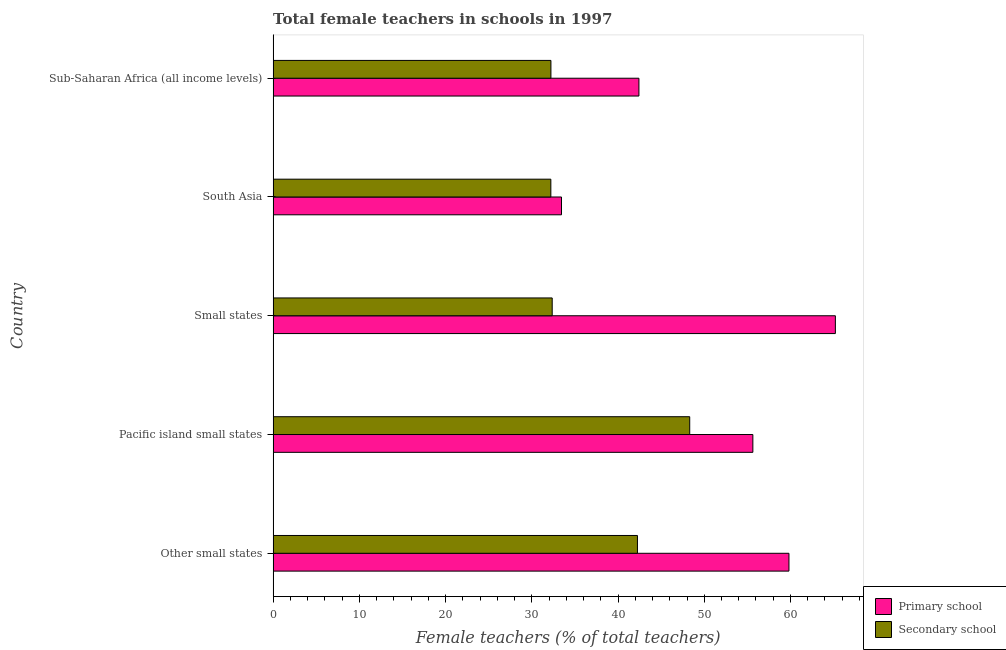How many groups of bars are there?
Provide a succinct answer. 5. How many bars are there on the 4th tick from the top?
Your answer should be very brief. 2. How many bars are there on the 3rd tick from the bottom?
Your answer should be very brief. 2. What is the label of the 3rd group of bars from the top?
Your answer should be compact. Small states. What is the percentage of female teachers in primary schools in Other small states?
Give a very brief answer. 59.82. Across all countries, what is the maximum percentage of female teachers in primary schools?
Give a very brief answer. 65.21. Across all countries, what is the minimum percentage of female teachers in secondary schools?
Your answer should be very brief. 32.21. In which country was the percentage of female teachers in primary schools maximum?
Keep it short and to the point. Small states. What is the total percentage of female teachers in primary schools in the graph?
Offer a very short reply. 256.54. What is the difference between the percentage of female teachers in secondary schools in Other small states and that in Sub-Saharan Africa (all income levels)?
Your answer should be compact. 10.04. What is the difference between the percentage of female teachers in secondary schools in Pacific island small states and the percentage of female teachers in primary schools in Sub-Saharan Africa (all income levels)?
Make the answer very short. 5.89. What is the average percentage of female teachers in secondary schools per country?
Your answer should be very brief. 37.47. What is the difference between the percentage of female teachers in secondary schools and percentage of female teachers in primary schools in Other small states?
Your answer should be compact. -17.57. In how many countries, is the percentage of female teachers in primary schools greater than 18 %?
Keep it short and to the point. 5. What is the ratio of the percentage of female teachers in primary schools in Small states to that in Sub-Saharan Africa (all income levels)?
Make the answer very short. 1.54. Is the percentage of female teachers in secondary schools in Pacific island small states less than that in South Asia?
Your response must be concise. No. Is the difference between the percentage of female teachers in secondary schools in Pacific island small states and South Asia greater than the difference between the percentage of female teachers in primary schools in Pacific island small states and South Asia?
Ensure brevity in your answer.  No. What is the difference between the highest and the second highest percentage of female teachers in secondary schools?
Your response must be concise. 6.06. What is the difference between the highest and the lowest percentage of female teachers in primary schools?
Provide a short and direct response. 31.76. Is the sum of the percentage of female teachers in primary schools in Pacific island small states and Small states greater than the maximum percentage of female teachers in secondary schools across all countries?
Your answer should be very brief. Yes. What does the 2nd bar from the top in South Asia represents?
Your response must be concise. Primary school. What does the 2nd bar from the bottom in Pacific island small states represents?
Offer a terse response. Secondary school. How many bars are there?
Offer a very short reply. 10. Are all the bars in the graph horizontal?
Give a very brief answer. Yes. How many countries are there in the graph?
Ensure brevity in your answer.  5. Are the values on the major ticks of X-axis written in scientific E-notation?
Provide a short and direct response. No. Where does the legend appear in the graph?
Your response must be concise. Bottom right. What is the title of the graph?
Provide a short and direct response. Total female teachers in schools in 1997. What is the label or title of the X-axis?
Make the answer very short. Female teachers (% of total teachers). What is the Female teachers (% of total teachers) of Primary school in Other small states?
Your response must be concise. 59.82. What is the Female teachers (% of total teachers) in Secondary school in Other small states?
Offer a terse response. 42.25. What is the Female teachers (% of total teachers) in Primary school in Pacific island small states?
Your response must be concise. 55.64. What is the Female teachers (% of total teachers) of Secondary school in Pacific island small states?
Your answer should be very brief. 48.32. What is the Female teachers (% of total teachers) in Primary school in Small states?
Keep it short and to the point. 65.21. What is the Female teachers (% of total teachers) in Secondary school in Small states?
Offer a very short reply. 32.37. What is the Female teachers (% of total teachers) in Primary school in South Asia?
Provide a succinct answer. 33.45. What is the Female teachers (% of total teachers) of Secondary school in South Asia?
Ensure brevity in your answer.  32.21. What is the Female teachers (% of total teachers) in Primary school in Sub-Saharan Africa (all income levels)?
Give a very brief answer. 42.43. What is the Female teachers (% of total teachers) of Secondary school in Sub-Saharan Africa (all income levels)?
Make the answer very short. 32.22. Across all countries, what is the maximum Female teachers (% of total teachers) of Primary school?
Your response must be concise. 65.21. Across all countries, what is the maximum Female teachers (% of total teachers) in Secondary school?
Your answer should be compact. 48.32. Across all countries, what is the minimum Female teachers (% of total teachers) of Primary school?
Offer a very short reply. 33.45. Across all countries, what is the minimum Female teachers (% of total teachers) in Secondary school?
Provide a succinct answer. 32.21. What is the total Female teachers (% of total teachers) in Primary school in the graph?
Your answer should be compact. 256.54. What is the total Female teachers (% of total teachers) in Secondary school in the graph?
Provide a short and direct response. 187.37. What is the difference between the Female teachers (% of total teachers) of Primary school in Other small states and that in Pacific island small states?
Your answer should be very brief. 4.19. What is the difference between the Female teachers (% of total teachers) in Secondary school in Other small states and that in Pacific island small states?
Offer a terse response. -6.06. What is the difference between the Female teachers (% of total teachers) in Primary school in Other small states and that in Small states?
Provide a short and direct response. -5.39. What is the difference between the Female teachers (% of total teachers) in Secondary school in Other small states and that in Small states?
Your answer should be very brief. 9.89. What is the difference between the Female teachers (% of total teachers) in Primary school in Other small states and that in South Asia?
Your answer should be very brief. 26.38. What is the difference between the Female teachers (% of total teachers) in Secondary school in Other small states and that in South Asia?
Provide a succinct answer. 10.04. What is the difference between the Female teachers (% of total teachers) in Primary school in Other small states and that in Sub-Saharan Africa (all income levels)?
Your response must be concise. 17.4. What is the difference between the Female teachers (% of total teachers) of Secondary school in Other small states and that in Sub-Saharan Africa (all income levels)?
Keep it short and to the point. 10.04. What is the difference between the Female teachers (% of total teachers) in Primary school in Pacific island small states and that in Small states?
Offer a terse response. -9.57. What is the difference between the Female teachers (% of total teachers) in Secondary school in Pacific island small states and that in Small states?
Provide a short and direct response. 15.95. What is the difference between the Female teachers (% of total teachers) in Primary school in Pacific island small states and that in South Asia?
Provide a succinct answer. 22.19. What is the difference between the Female teachers (% of total teachers) in Secondary school in Pacific island small states and that in South Asia?
Keep it short and to the point. 16.11. What is the difference between the Female teachers (% of total teachers) of Primary school in Pacific island small states and that in Sub-Saharan Africa (all income levels)?
Ensure brevity in your answer.  13.21. What is the difference between the Female teachers (% of total teachers) in Secondary school in Pacific island small states and that in Sub-Saharan Africa (all income levels)?
Provide a short and direct response. 16.1. What is the difference between the Female teachers (% of total teachers) in Primary school in Small states and that in South Asia?
Provide a succinct answer. 31.76. What is the difference between the Female teachers (% of total teachers) of Secondary school in Small states and that in South Asia?
Your response must be concise. 0.16. What is the difference between the Female teachers (% of total teachers) in Primary school in Small states and that in Sub-Saharan Africa (all income levels)?
Provide a short and direct response. 22.78. What is the difference between the Female teachers (% of total teachers) in Secondary school in Small states and that in Sub-Saharan Africa (all income levels)?
Provide a succinct answer. 0.15. What is the difference between the Female teachers (% of total teachers) in Primary school in South Asia and that in Sub-Saharan Africa (all income levels)?
Offer a very short reply. -8.98. What is the difference between the Female teachers (% of total teachers) of Secondary school in South Asia and that in Sub-Saharan Africa (all income levels)?
Give a very brief answer. -0.01. What is the difference between the Female teachers (% of total teachers) of Primary school in Other small states and the Female teachers (% of total teachers) of Secondary school in Pacific island small states?
Your answer should be very brief. 11.51. What is the difference between the Female teachers (% of total teachers) of Primary school in Other small states and the Female teachers (% of total teachers) of Secondary school in Small states?
Offer a terse response. 27.46. What is the difference between the Female teachers (% of total teachers) in Primary school in Other small states and the Female teachers (% of total teachers) in Secondary school in South Asia?
Your response must be concise. 27.61. What is the difference between the Female teachers (% of total teachers) of Primary school in Other small states and the Female teachers (% of total teachers) of Secondary school in Sub-Saharan Africa (all income levels)?
Keep it short and to the point. 27.61. What is the difference between the Female teachers (% of total teachers) of Primary school in Pacific island small states and the Female teachers (% of total teachers) of Secondary school in Small states?
Your answer should be very brief. 23.27. What is the difference between the Female teachers (% of total teachers) of Primary school in Pacific island small states and the Female teachers (% of total teachers) of Secondary school in South Asia?
Provide a short and direct response. 23.43. What is the difference between the Female teachers (% of total teachers) of Primary school in Pacific island small states and the Female teachers (% of total teachers) of Secondary school in Sub-Saharan Africa (all income levels)?
Your answer should be compact. 23.42. What is the difference between the Female teachers (% of total teachers) of Primary school in Small states and the Female teachers (% of total teachers) of Secondary school in South Asia?
Your answer should be very brief. 33. What is the difference between the Female teachers (% of total teachers) of Primary school in Small states and the Female teachers (% of total teachers) of Secondary school in Sub-Saharan Africa (all income levels)?
Your response must be concise. 32.99. What is the difference between the Female teachers (% of total teachers) in Primary school in South Asia and the Female teachers (% of total teachers) in Secondary school in Sub-Saharan Africa (all income levels)?
Make the answer very short. 1.23. What is the average Female teachers (% of total teachers) in Primary school per country?
Your answer should be compact. 51.31. What is the average Female teachers (% of total teachers) of Secondary school per country?
Make the answer very short. 37.47. What is the difference between the Female teachers (% of total teachers) in Primary school and Female teachers (% of total teachers) in Secondary school in Other small states?
Provide a short and direct response. 17.57. What is the difference between the Female teachers (% of total teachers) of Primary school and Female teachers (% of total teachers) of Secondary school in Pacific island small states?
Your answer should be very brief. 7.32. What is the difference between the Female teachers (% of total teachers) in Primary school and Female teachers (% of total teachers) in Secondary school in Small states?
Keep it short and to the point. 32.84. What is the difference between the Female teachers (% of total teachers) in Primary school and Female teachers (% of total teachers) in Secondary school in South Asia?
Ensure brevity in your answer.  1.24. What is the difference between the Female teachers (% of total teachers) in Primary school and Female teachers (% of total teachers) in Secondary school in Sub-Saharan Africa (all income levels)?
Make the answer very short. 10.21. What is the ratio of the Female teachers (% of total teachers) in Primary school in Other small states to that in Pacific island small states?
Make the answer very short. 1.08. What is the ratio of the Female teachers (% of total teachers) of Secondary school in Other small states to that in Pacific island small states?
Your response must be concise. 0.87. What is the ratio of the Female teachers (% of total teachers) of Primary school in Other small states to that in Small states?
Keep it short and to the point. 0.92. What is the ratio of the Female teachers (% of total teachers) in Secondary school in Other small states to that in Small states?
Provide a succinct answer. 1.31. What is the ratio of the Female teachers (% of total teachers) of Primary school in Other small states to that in South Asia?
Give a very brief answer. 1.79. What is the ratio of the Female teachers (% of total teachers) in Secondary school in Other small states to that in South Asia?
Offer a terse response. 1.31. What is the ratio of the Female teachers (% of total teachers) in Primary school in Other small states to that in Sub-Saharan Africa (all income levels)?
Give a very brief answer. 1.41. What is the ratio of the Female teachers (% of total teachers) in Secondary school in Other small states to that in Sub-Saharan Africa (all income levels)?
Give a very brief answer. 1.31. What is the ratio of the Female teachers (% of total teachers) in Primary school in Pacific island small states to that in Small states?
Ensure brevity in your answer.  0.85. What is the ratio of the Female teachers (% of total teachers) of Secondary school in Pacific island small states to that in Small states?
Your response must be concise. 1.49. What is the ratio of the Female teachers (% of total teachers) of Primary school in Pacific island small states to that in South Asia?
Your answer should be compact. 1.66. What is the ratio of the Female teachers (% of total teachers) of Primary school in Pacific island small states to that in Sub-Saharan Africa (all income levels)?
Offer a terse response. 1.31. What is the ratio of the Female teachers (% of total teachers) in Secondary school in Pacific island small states to that in Sub-Saharan Africa (all income levels)?
Provide a short and direct response. 1.5. What is the ratio of the Female teachers (% of total teachers) of Primary school in Small states to that in South Asia?
Provide a short and direct response. 1.95. What is the ratio of the Female teachers (% of total teachers) of Secondary school in Small states to that in South Asia?
Offer a terse response. 1. What is the ratio of the Female teachers (% of total teachers) of Primary school in Small states to that in Sub-Saharan Africa (all income levels)?
Keep it short and to the point. 1.54. What is the ratio of the Female teachers (% of total teachers) of Primary school in South Asia to that in Sub-Saharan Africa (all income levels)?
Ensure brevity in your answer.  0.79. What is the ratio of the Female teachers (% of total teachers) in Secondary school in South Asia to that in Sub-Saharan Africa (all income levels)?
Your response must be concise. 1. What is the difference between the highest and the second highest Female teachers (% of total teachers) in Primary school?
Provide a succinct answer. 5.39. What is the difference between the highest and the second highest Female teachers (% of total teachers) in Secondary school?
Provide a succinct answer. 6.06. What is the difference between the highest and the lowest Female teachers (% of total teachers) of Primary school?
Give a very brief answer. 31.76. What is the difference between the highest and the lowest Female teachers (% of total teachers) in Secondary school?
Your answer should be very brief. 16.11. 